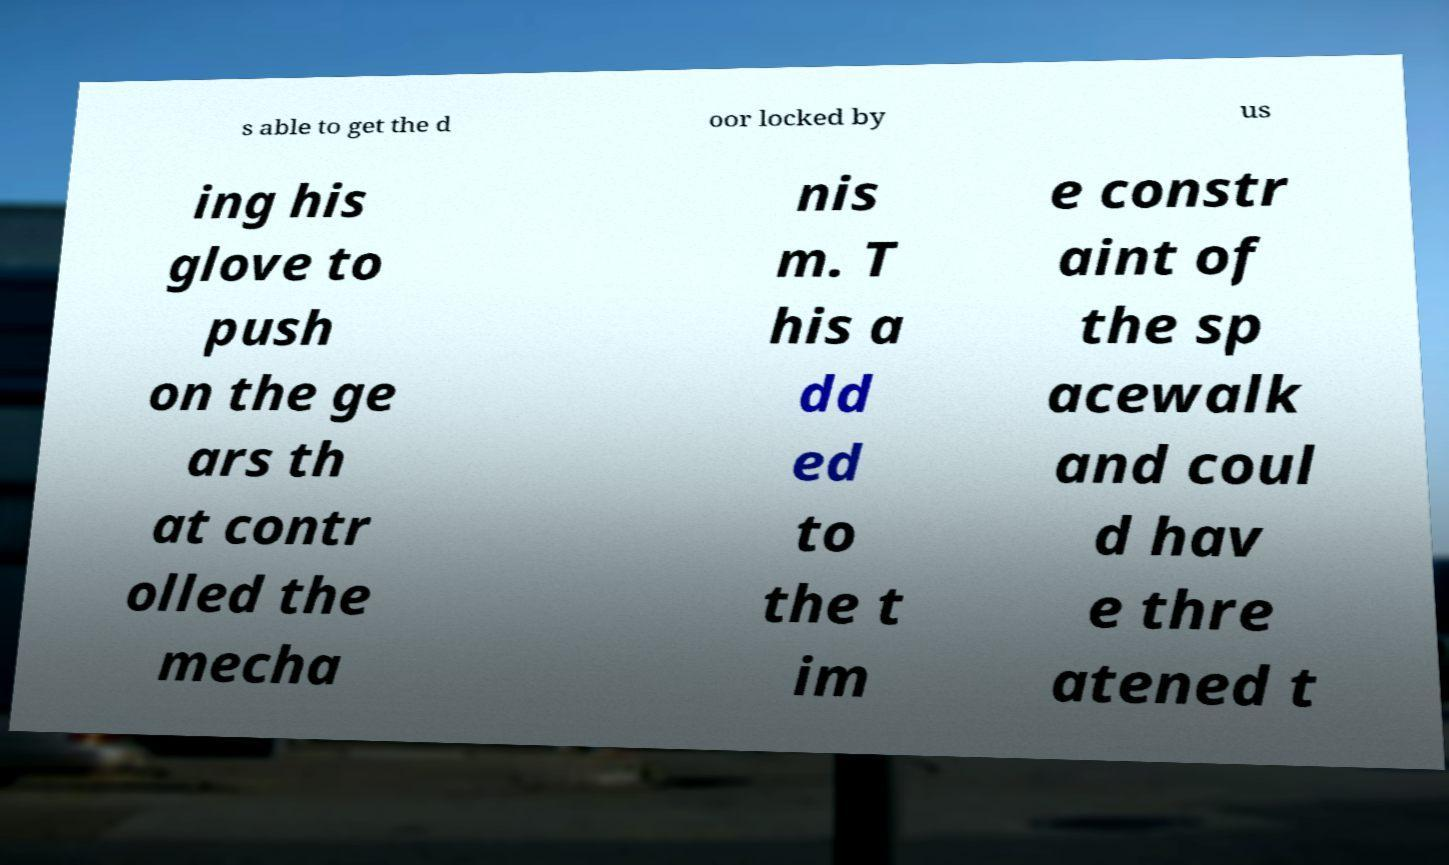I need the written content from this picture converted into text. Can you do that? s able to get the d oor locked by us ing his glove to push on the ge ars th at contr olled the mecha nis m. T his a dd ed to the t im e constr aint of the sp acewalk and coul d hav e thre atened t 